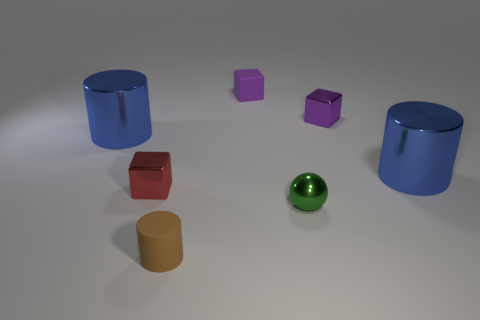There is a tiny metallic object that is behind the red object; is it the same color as the rubber cube?
Keep it short and to the point. Yes. What size is the metallic thing that is the same color as the small matte block?
Your answer should be very brief. Small. There is a cube that is to the right of the tiny rubber cylinder and left of the small shiny sphere; what size is it?
Keep it short and to the point. Small. What material is the blue cylinder right of the blue object that is behind the large metal object right of the red metal object?
Give a very brief answer. Metal. What is the material of the other tiny block that is the same color as the matte cube?
Ensure brevity in your answer.  Metal. Do the shiny cylinder to the right of the green object and the metal cylinder that is to the left of the brown matte thing have the same color?
Offer a very short reply. Yes. There is a matte thing behind the large blue cylinder in front of the blue thing that is to the left of the tiny purple metallic block; what shape is it?
Give a very brief answer. Cube. There is a thing that is both right of the small brown matte thing and left of the ball; what shape is it?
Make the answer very short. Cube. What number of small shiny cubes are behind the big blue shiny cylinder to the right of the small cylinder left of the small ball?
Ensure brevity in your answer.  1. The other matte object that is the same shape as the red thing is what size?
Your answer should be very brief. Small. 